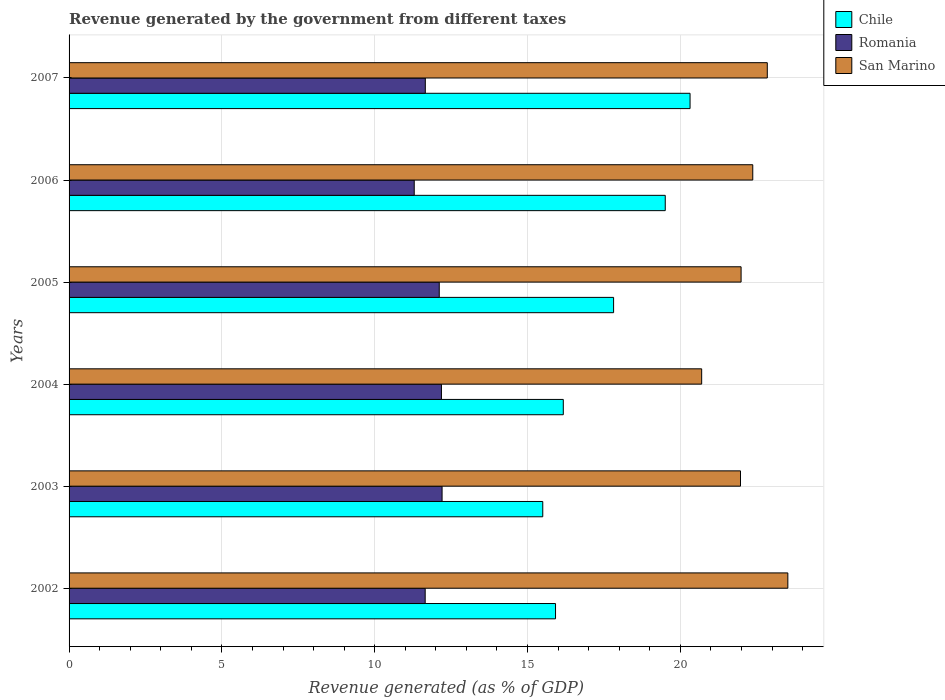How many groups of bars are there?
Provide a succinct answer. 6. Are the number of bars per tick equal to the number of legend labels?
Provide a succinct answer. Yes. Are the number of bars on each tick of the Y-axis equal?
Keep it short and to the point. Yes. How many bars are there on the 1st tick from the bottom?
Your answer should be very brief. 3. What is the label of the 6th group of bars from the top?
Give a very brief answer. 2002. What is the revenue generated by the government in Chile in 2005?
Ensure brevity in your answer.  17.82. Across all years, what is the maximum revenue generated by the government in Chile?
Your response must be concise. 20.32. Across all years, what is the minimum revenue generated by the government in Chile?
Keep it short and to the point. 15.5. In which year was the revenue generated by the government in Romania maximum?
Keep it short and to the point. 2003. What is the total revenue generated by the government in San Marino in the graph?
Provide a succinct answer. 133.39. What is the difference between the revenue generated by the government in Romania in 2004 and that in 2006?
Make the answer very short. 0.89. What is the difference between the revenue generated by the government in Romania in 2006 and the revenue generated by the government in San Marino in 2003?
Make the answer very short. -10.68. What is the average revenue generated by the government in San Marino per year?
Provide a succinct answer. 22.23. In the year 2003, what is the difference between the revenue generated by the government in Chile and revenue generated by the government in Romania?
Your response must be concise. 3.29. What is the ratio of the revenue generated by the government in San Marino in 2003 to that in 2006?
Offer a terse response. 0.98. Is the revenue generated by the government in Chile in 2002 less than that in 2006?
Provide a succinct answer. Yes. What is the difference between the highest and the second highest revenue generated by the government in Chile?
Ensure brevity in your answer.  0.81. What is the difference between the highest and the lowest revenue generated by the government in Romania?
Offer a very short reply. 0.91. In how many years, is the revenue generated by the government in Chile greater than the average revenue generated by the government in Chile taken over all years?
Offer a terse response. 3. Is the sum of the revenue generated by the government in San Marino in 2004 and 2007 greater than the maximum revenue generated by the government in Romania across all years?
Your answer should be compact. Yes. What does the 3rd bar from the top in 2002 represents?
Give a very brief answer. Chile. What does the 3rd bar from the bottom in 2007 represents?
Offer a terse response. San Marino. How many bars are there?
Give a very brief answer. 18. Are all the bars in the graph horizontal?
Keep it short and to the point. Yes. How many years are there in the graph?
Your answer should be very brief. 6. Does the graph contain grids?
Your response must be concise. Yes. What is the title of the graph?
Provide a succinct answer. Revenue generated by the government from different taxes. Does "Mongolia" appear as one of the legend labels in the graph?
Your answer should be compact. No. What is the label or title of the X-axis?
Make the answer very short. Revenue generated (as % of GDP). What is the Revenue generated (as % of GDP) in Chile in 2002?
Ensure brevity in your answer.  15.92. What is the Revenue generated (as % of GDP) of Romania in 2002?
Your answer should be compact. 11.65. What is the Revenue generated (as % of GDP) in San Marino in 2002?
Ensure brevity in your answer.  23.52. What is the Revenue generated (as % of GDP) of Chile in 2003?
Give a very brief answer. 15.5. What is the Revenue generated (as % of GDP) of Romania in 2003?
Ensure brevity in your answer.  12.2. What is the Revenue generated (as % of GDP) in San Marino in 2003?
Keep it short and to the point. 21.97. What is the Revenue generated (as % of GDP) of Chile in 2004?
Your answer should be compact. 16.17. What is the Revenue generated (as % of GDP) in Romania in 2004?
Offer a terse response. 12.18. What is the Revenue generated (as % of GDP) of San Marino in 2004?
Keep it short and to the point. 20.7. What is the Revenue generated (as % of GDP) in Chile in 2005?
Provide a succinct answer. 17.82. What is the Revenue generated (as % of GDP) of Romania in 2005?
Offer a very short reply. 12.11. What is the Revenue generated (as % of GDP) of San Marino in 2005?
Your answer should be compact. 21.99. What is the Revenue generated (as % of GDP) in Chile in 2006?
Provide a short and direct response. 19.51. What is the Revenue generated (as % of GDP) in Romania in 2006?
Keep it short and to the point. 11.29. What is the Revenue generated (as % of GDP) in San Marino in 2006?
Give a very brief answer. 22.37. What is the Revenue generated (as % of GDP) of Chile in 2007?
Keep it short and to the point. 20.32. What is the Revenue generated (as % of GDP) in Romania in 2007?
Your response must be concise. 11.66. What is the Revenue generated (as % of GDP) in San Marino in 2007?
Your answer should be very brief. 22.85. Across all years, what is the maximum Revenue generated (as % of GDP) of Chile?
Your answer should be very brief. 20.32. Across all years, what is the maximum Revenue generated (as % of GDP) in Romania?
Provide a succinct answer. 12.2. Across all years, what is the maximum Revenue generated (as % of GDP) in San Marino?
Offer a very short reply. 23.52. Across all years, what is the minimum Revenue generated (as % of GDP) in Chile?
Offer a terse response. 15.5. Across all years, what is the minimum Revenue generated (as % of GDP) in Romania?
Provide a succinct answer. 11.29. Across all years, what is the minimum Revenue generated (as % of GDP) in San Marino?
Provide a succinct answer. 20.7. What is the total Revenue generated (as % of GDP) in Chile in the graph?
Ensure brevity in your answer.  105.23. What is the total Revenue generated (as % of GDP) of Romania in the graph?
Provide a short and direct response. 71.1. What is the total Revenue generated (as % of GDP) in San Marino in the graph?
Provide a short and direct response. 133.39. What is the difference between the Revenue generated (as % of GDP) of Chile in 2002 and that in 2003?
Your answer should be compact. 0.42. What is the difference between the Revenue generated (as % of GDP) in Romania in 2002 and that in 2003?
Give a very brief answer. -0.55. What is the difference between the Revenue generated (as % of GDP) in San Marino in 2002 and that in 2003?
Provide a succinct answer. 1.55. What is the difference between the Revenue generated (as % of GDP) of Chile in 2002 and that in 2004?
Make the answer very short. -0.25. What is the difference between the Revenue generated (as % of GDP) of Romania in 2002 and that in 2004?
Provide a succinct answer. -0.53. What is the difference between the Revenue generated (as % of GDP) in San Marino in 2002 and that in 2004?
Ensure brevity in your answer.  2.82. What is the difference between the Revenue generated (as % of GDP) in Chile in 2002 and that in 2005?
Keep it short and to the point. -1.9. What is the difference between the Revenue generated (as % of GDP) of Romania in 2002 and that in 2005?
Offer a very short reply. -0.46. What is the difference between the Revenue generated (as % of GDP) of San Marino in 2002 and that in 2005?
Your answer should be compact. 1.53. What is the difference between the Revenue generated (as % of GDP) of Chile in 2002 and that in 2006?
Make the answer very short. -3.59. What is the difference between the Revenue generated (as % of GDP) of Romania in 2002 and that in 2006?
Your answer should be very brief. 0.36. What is the difference between the Revenue generated (as % of GDP) in San Marino in 2002 and that in 2006?
Keep it short and to the point. 1.15. What is the difference between the Revenue generated (as % of GDP) of Chile in 2002 and that in 2007?
Provide a short and direct response. -4.4. What is the difference between the Revenue generated (as % of GDP) of Romania in 2002 and that in 2007?
Your answer should be very brief. -0. What is the difference between the Revenue generated (as % of GDP) of San Marino in 2002 and that in 2007?
Provide a short and direct response. 0.67. What is the difference between the Revenue generated (as % of GDP) in Chile in 2003 and that in 2004?
Your answer should be very brief. -0.67. What is the difference between the Revenue generated (as % of GDP) of Romania in 2003 and that in 2004?
Offer a terse response. 0.02. What is the difference between the Revenue generated (as % of GDP) in San Marino in 2003 and that in 2004?
Offer a terse response. 1.27. What is the difference between the Revenue generated (as % of GDP) in Chile in 2003 and that in 2005?
Provide a succinct answer. -2.32. What is the difference between the Revenue generated (as % of GDP) in Romania in 2003 and that in 2005?
Give a very brief answer. 0.09. What is the difference between the Revenue generated (as % of GDP) of San Marino in 2003 and that in 2005?
Your answer should be very brief. -0.02. What is the difference between the Revenue generated (as % of GDP) of Chile in 2003 and that in 2006?
Provide a succinct answer. -4.01. What is the difference between the Revenue generated (as % of GDP) in Romania in 2003 and that in 2006?
Make the answer very short. 0.91. What is the difference between the Revenue generated (as % of GDP) of San Marino in 2003 and that in 2006?
Keep it short and to the point. -0.4. What is the difference between the Revenue generated (as % of GDP) of Chile in 2003 and that in 2007?
Provide a succinct answer. -4.82. What is the difference between the Revenue generated (as % of GDP) in Romania in 2003 and that in 2007?
Keep it short and to the point. 0.55. What is the difference between the Revenue generated (as % of GDP) in San Marino in 2003 and that in 2007?
Ensure brevity in your answer.  -0.88. What is the difference between the Revenue generated (as % of GDP) in Chile in 2004 and that in 2005?
Make the answer very short. -1.65. What is the difference between the Revenue generated (as % of GDP) of Romania in 2004 and that in 2005?
Ensure brevity in your answer.  0.07. What is the difference between the Revenue generated (as % of GDP) in San Marino in 2004 and that in 2005?
Ensure brevity in your answer.  -1.29. What is the difference between the Revenue generated (as % of GDP) of Chile in 2004 and that in 2006?
Your answer should be compact. -3.34. What is the difference between the Revenue generated (as % of GDP) in Romania in 2004 and that in 2006?
Ensure brevity in your answer.  0.89. What is the difference between the Revenue generated (as % of GDP) in San Marino in 2004 and that in 2006?
Offer a terse response. -1.67. What is the difference between the Revenue generated (as % of GDP) in Chile in 2004 and that in 2007?
Make the answer very short. -4.15. What is the difference between the Revenue generated (as % of GDP) of Romania in 2004 and that in 2007?
Your answer should be very brief. 0.53. What is the difference between the Revenue generated (as % of GDP) of San Marino in 2004 and that in 2007?
Offer a terse response. -2.15. What is the difference between the Revenue generated (as % of GDP) of Chile in 2005 and that in 2006?
Provide a short and direct response. -1.69. What is the difference between the Revenue generated (as % of GDP) of Romania in 2005 and that in 2006?
Your answer should be compact. 0.82. What is the difference between the Revenue generated (as % of GDP) of San Marino in 2005 and that in 2006?
Make the answer very short. -0.38. What is the difference between the Revenue generated (as % of GDP) of Chile in 2005 and that in 2007?
Offer a terse response. -2.5. What is the difference between the Revenue generated (as % of GDP) of Romania in 2005 and that in 2007?
Provide a short and direct response. 0.46. What is the difference between the Revenue generated (as % of GDP) in San Marino in 2005 and that in 2007?
Offer a terse response. -0.86. What is the difference between the Revenue generated (as % of GDP) in Chile in 2006 and that in 2007?
Provide a succinct answer. -0.81. What is the difference between the Revenue generated (as % of GDP) in Romania in 2006 and that in 2007?
Your answer should be compact. -0.36. What is the difference between the Revenue generated (as % of GDP) of San Marino in 2006 and that in 2007?
Keep it short and to the point. -0.48. What is the difference between the Revenue generated (as % of GDP) of Chile in 2002 and the Revenue generated (as % of GDP) of Romania in 2003?
Offer a very short reply. 3.71. What is the difference between the Revenue generated (as % of GDP) in Chile in 2002 and the Revenue generated (as % of GDP) in San Marino in 2003?
Your answer should be compact. -6.05. What is the difference between the Revenue generated (as % of GDP) in Romania in 2002 and the Revenue generated (as % of GDP) in San Marino in 2003?
Ensure brevity in your answer.  -10.32. What is the difference between the Revenue generated (as % of GDP) in Chile in 2002 and the Revenue generated (as % of GDP) in Romania in 2004?
Your answer should be very brief. 3.73. What is the difference between the Revenue generated (as % of GDP) of Chile in 2002 and the Revenue generated (as % of GDP) of San Marino in 2004?
Offer a very short reply. -4.78. What is the difference between the Revenue generated (as % of GDP) of Romania in 2002 and the Revenue generated (as % of GDP) of San Marino in 2004?
Provide a short and direct response. -9.05. What is the difference between the Revenue generated (as % of GDP) of Chile in 2002 and the Revenue generated (as % of GDP) of Romania in 2005?
Ensure brevity in your answer.  3.8. What is the difference between the Revenue generated (as % of GDP) of Chile in 2002 and the Revenue generated (as % of GDP) of San Marino in 2005?
Give a very brief answer. -6.07. What is the difference between the Revenue generated (as % of GDP) in Romania in 2002 and the Revenue generated (as % of GDP) in San Marino in 2005?
Offer a terse response. -10.34. What is the difference between the Revenue generated (as % of GDP) of Chile in 2002 and the Revenue generated (as % of GDP) of Romania in 2006?
Offer a terse response. 4.62. What is the difference between the Revenue generated (as % of GDP) of Chile in 2002 and the Revenue generated (as % of GDP) of San Marino in 2006?
Keep it short and to the point. -6.45. What is the difference between the Revenue generated (as % of GDP) in Romania in 2002 and the Revenue generated (as % of GDP) in San Marino in 2006?
Your answer should be very brief. -10.72. What is the difference between the Revenue generated (as % of GDP) in Chile in 2002 and the Revenue generated (as % of GDP) in Romania in 2007?
Your answer should be very brief. 4.26. What is the difference between the Revenue generated (as % of GDP) of Chile in 2002 and the Revenue generated (as % of GDP) of San Marino in 2007?
Provide a short and direct response. -6.93. What is the difference between the Revenue generated (as % of GDP) of Romania in 2002 and the Revenue generated (as % of GDP) of San Marino in 2007?
Keep it short and to the point. -11.19. What is the difference between the Revenue generated (as % of GDP) in Chile in 2003 and the Revenue generated (as % of GDP) in Romania in 2004?
Keep it short and to the point. 3.31. What is the difference between the Revenue generated (as % of GDP) in Chile in 2003 and the Revenue generated (as % of GDP) in San Marino in 2004?
Make the answer very short. -5.2. What is the difference between the Revenue generated (as % of GDP) of Romania in 2003 and the Revenue generated (as % of GDP) of San Marino in 2004?
Provide a short and direct response. -8.49. What is the difference between the Revenue generated (as % of GDP) of Chile in 2003 and the Revenue generated (as % of GDP) of Romania in 2005?
Make the answer very short. 3.39. What is the difference between the Revenue generated (as % of GDP) of Chile in 2003 and the Revenue generated (as % of GDP) of San Marino in 2005?
Offer a very short reply. -6.49. What is the difference between the Revenue generated (as % of GDP) in Romania in 2003 and the Revenue generated (as % of GDP) in San Marino in 2005?
Ensure brevity in your answer.  -9.78. What is the difference between the Revenue generated (as % of GDP) in Chile in 2003 and the Revenue generated (as % of GDP) in Romania in 2006?
Provide a short and direct response. 4.21. What is the difference between the Revenue generated (as % of GDP) in Chile in 2003 and the Revenue generated (as % of GDP) in San Marino in 2006?
Your answer should be compact. -6.87. What is the difference between the Revenue generated (as % of GDP) in Romania in 2003 and the Revenue generated (as % of GDP) in San Marino in 2006?
Provide a succinct answer. -10.17. What is the difference between the Revenue generated (as % of GDP) of Chile in 2003 and the Revenue generated (as % of GDP) of Romania in 2007?
Your answer should be very brief. 3.84. What is the difference between the Revenue generated (as % of GDP) in Chile in 2003 and the Revenue generated (as % of GDP) in San Marino in 2007?
Provide a short and direct response. -7.35. What is the difference between the Revenue generated (as % of GDP) in Romania in 2003 and the Revenue generated (as % of GDP) in San Marino in 2007?
Keep it short and to the point. -10.64. What is the difference between the Revenue generated (as % of GDP) in Chile in 2004 and the Revenue generated (as % of GDP) in Romania in 2005?
Ensure brevity in your answer.  4.06. What is the difference between the Revenue generated (as % of GDP) in Chile in 2004 and the Revenue generated (as % of GDP) in San Marino in 2005?
Your response must be concise. -5.82. What is the difference between the Revenue generated (as % of GDP) of Romania in 2004 and the Revenue generated (as % of GDP) of San Marino in 2005?
Give a very brief answer. -9.8. What is the difference between the Revenue generated (as % of GDP) of Chile in 2004 and the Revenue generated (as % of GDP) of Romania in 2006?
Keep it short and to the point. 4.88. What is the difference between the Revenue generated (as % of GDP) of Chile in 2004 and the Revenue generated (as % of GDP) of San Marino in 2006?
Your answer should be compact. -6.2. What is the difference between the Revenue generated (as % of GDP) in Romania in 2004 and the Revenue generated (as % of GDP) in San Marino in 2006?
Provide a succinct answer. -10.19. What is the difference between the Revenue generated (as % of GDP) of Chile in 2004 and the Revenue generated (as % of GDP) of Romania in 2007?
Give a very brief answer. 4.51. What is the difference between the Revenue generated (as % of GDP) of Chile in 2004 and the Revenue generated (as % of GDP) of San Marino in 2007?
Make the answer very short. -6.67. What is the difference between the Revenue generated (as % of GDP) in Romania in 2004 and the Revenue generated (as % of GDP) in San Marino in 2007?
Your answer should be compact. -10.66. What is the difference between the Revenue generated (as % of GDP) of Chile in 2005 and the Revenue generated (as % of GDP) of Romania in 2006?
Ensure brevity in your answer.  6.52. What is the difference between the Revenue generated (as % of GDP) in Chile in 2005 and the Revenue generated (as % of GDP) in San Marino in 2006?
Give a very brief answer. -4.55. What is the difference between the Revenue generated (as % of GDP) in Romania in 2005 and the Revenue generated (as % of GDP) in San Marino in 2006?
Keep it short and to the point. -10.26. What is the difference between the Revenue generated (as % of GDP) of Chile in 2005 and the Revenue generated (as % of GDP) of Romania in 2007?
Ensure brevity in your answer.  6.16. What is the difference between the Revenue generated (as % of GDP) of Chile in 2005 and the Revenue generated (as % of GDP) of San Marino in 2007?
Your answer should be very brief. -5.03. What is the difference between the Revenue generated (as % of GDP) of Romania in 2005 and the Revenue generated (as % of GDP) of San Marino in 2007?
Offer a terse response. -10.73. What is the difference between the Revenue generated (as % of GDP) in Chile in 2006 and the Revenue generated (as % of GDP) in Romania in 2007?
Offer a terse response. 7.85. What is the difference between the Revenue generated (as % of GDP) of Chile in 2006 and the Revenue generated (as % of GDP) of San Marino in 2007?
Ensure brevity in your answer.  -3.34. What is the difference between the Revenue generated (as % of GDP) of Romania in 2006 and the Revenue generated (as % of GDP) of San Marino in 2007?
Make the answer very short. -11.55. What is the average Revenue generated (as % of GDP) of Chile per year?
Give a very brief answer. 17.54. What is the average Revenue generated (as % of GDP) in Romania per year?
Provide a succinct answer. 11.85. What is the average Revenue generated (as % of GDP) in San Marino per year?
Keep it short and to the point. 22.23. In the year 2002, what is the difference between the Revenue generated (as % of GDP) of Chile and Revenue generated (as % of GDP) of Romania?
Make the answer very short. 4.27. In the year 2002, what is the difference between the Revenue generated (as % of GDP) in Chile and Revenue generated (as % of GDP) in San Marino?
Provide a succinct answer. -7.6. In the year 2002, what is the difference between the Revenue generated (as % of GDP) in Romania and Revenue generated (as % of GDP) in San Marino?
Your answer should be very brief. -11.87. In the year 2003, what is the difference between the Revenue generated (as % of GDP) of Chile and Revenue generated (as % of GDP) of Romania?
Your answer should be very brief. 3.29. In the year 2003, what is the difference between the Revenue generated (as % of GDP) in Chile and Revenue generated (as % of GDP) in San Marino?
Give a very brief answer. -6.47. In the year 2003, what is the difference between the Revenue generated (as % of GDP) in Romania and Revenue generated (as % of GDP) in San Marino?
Offer a very short reply. -9.76. In the year 2004, what is the difference between the Revenue generated (as % of GDP) of Chile and Revenue generated (as % of GDP) of Romania?
Your answer should be very brief. 3.99. In the year 2004, what is the difference between the Revenue generated (as % of GDP) in Chile and Revenue generated (as % of GDP) in San Marino?
Make the answer very short. -4.53. In the year 2004, what is the difference between the Revenue generated (as % of GDP) in Romania and Revenue generated (as % of GDP) in San Marino?
Offer a terse response. -8.51. In the year 2005, what is the difference between the Revenue generated (as % of GDP) of Chile and Revenue generated (as % of GDP) of Romania?
Your response must be concise. 5.7. In the year 2005, what is the difference between the Revenue generated (as % of GDP) of Chile and Revenue generated (as % of GDP) of San Marino?
Provide a succinct answer. -4.17. In the year 2005, what is the difference between the Revenue generated (as % of GDP) of Romania and Revenue generated (as % of GDP) of San Marino?
Ensure brevity in your answer.  -9.88. In the year 2006, what is the difference between the Revenue generated (as % of GDP) of Chile and Revenue generated (as % of GDP) of Romania?
Your answer should be compact. 8.21. In the year 2006, what is the difference between the Revenue generated (as % of GDP) in Chile and Revenue generated (as % of GDP) in San Marino?
Offer a terse response. -2.86. In the year 2006, what is the difference between the Revenue generated (as % of GDP) of Romania and Revenue generated (as % of GDP) of San Marino?
Give a very brief answer. -11.08. In the year 2007, what is the difference between the Revenue generated (as % of GDP) in Chile and Revenue generated (as % of GDP) in Romania?
Keep it short and to the point. 8.66. In the year 2007, what is the difference between the Revenue generated (as % of GDP) in Chile and Revenue generated (as % of GDP) in San Marino?
Your response must be concise. -2.53. In the year 2007, what is the difference between the Revenue generated (as % of GDP) in Romania and Revenue generated (as % of GDP) in San Marino?
Offer a very short reply. -11.19. What is the ratio of the Revenue generated (as % of GDP) in Romania in 2002 to that in 2003?
Your answer should be very brief. 0.95. What is the ratio of the Revenue generated (as % of GDP) in San Marino in 2002 to that in 2003?
Provide a short and direct response. 1.07. What is the ratio of the Revenue generated (as % of GDP) of Chile in 2002 to that in 2004?
Your answer should be compact. 0.98. What is the ratio of the Revenue generated (as % of GDP) of Romania in 2002 to that in 2004?
Provide a succinct answer. 0.96. What is the ratio of the Revenue generated (as % of GDP) in San Marino in 2002 to that in 2004?
Provide a short and direct response. 1.14. What is the ratio of the Revenue generated (as % of GDP) of Chile in 2002 to that in 2005?
Make the answer very short. 0.89. What is the ratio of the Revenue generated (as % of GDP) in Romania in 2002 to that in 2005?
Your answer should be very brief. 0.96. What is the ratio of the Revenue generated (as % of GDP) of San Marino in 2002 to that in 2005?
Offer a very short reply. 1.07. What is the ratio of the Revenue generated (as % of GDP) of Chile in 2002 to that in 2006?
Your answer should be compact. 0.82. What is the ratio of the Revenue generated (as % of GDP) in Romania in 2002 to that in 2006?
Give a very brief answer. 1.03. What is the ratio of the Revenue generated (as % of GDP) in San Marino in 2002 to that in 2006?
Ensure brevity in your answer.  1.05. What is the ratio of the Revenue generated (as % of GDP) in Chile in 2002 to that in 2007?
Your answer should be compact. 0.78. What is the ratio of the Revenue generated (as % of GDP) in San Marino in 2002 to that in 2007?
Your response must be concise. 1.03. What is the ratio of the Revenue generated (as % of GDP) in Chile in 2003 to that in 2004?
Keep it short and to the point. 0.96. What is the ratio of the Revenue generated (as % of GDP) in San Marino in 2003 to that in 2004?
Offer a very short reply. 1.06. What is the ratio of the Revenue generated (as % of GDP) of Chile in 2003 to that in 2005?
Offer a terse response. 0.87. What is the ratio of the Revenue generated (as % of GDP) in Romania in 2003 to that in 2005?
Offer a terse response. 1.01. What is the ratio of the Revenue generated (as % of GDP) of Chile in 2003 to that in 2006?
Your answer should be very brief. 0.79. What is the ratio of the Revenue generated (as % of GDP) of Romania in 2003 to that in 2006?
Your response must be concise. 1.08. What is the ratio of the Revenue generated (as % of GDP) of San Marino in 2003 to that in 2006?
Give a very brief answer. 0.98. What is the ratio of the Revenue generated (as % of GDP) in Chile in 2003 to that in 2007?
Ensure brevity in your answer.  0.76. What is the ratio of the Revenue generated (as % of GDP) of Romania in 2003 to that in 2007?
Your response must be concise. 1.05. What is the ratio of the Revenue generated (as % of GDP) of San Marino in 2003 to that in 2007?
Offer a terse response. 0.96. What is the ratio of the Revenue generated (as % of GDP) in Chile in 2004 to that in 2005?
Provide a succinct answer. 0.91. What is the ratio of the Revenue generated (as % of GDP) in Romania in 2004 to that in 2005?
Offer a terse response. 1.01. What is the ratio of the Revenue generated (as % of GDP) of San Marino in 2004 to that in 2005?
Offer a very short reply. 0.94. What is the ratio of the Revenue generated (as % of GDP) in Chile in 2004 to that in 2006?
Offer a terse response. 0.83. What is the ratio of the Revenue generated (as % of GDP) in Romania in 2004 to that in 2006?
Make the answer very short. 1.08. What is the ratio of the Revenue generated (as % of GDP) of San Marino in 2004 to that in 2006?
Keep it short and to the point. 0.93. What is the ratio of the Revenue generated (as % of GDP) in Chile in 2004 to that in 2007?
Keep it short and to the point. 0.8. What is the ratio of the Revenue generated (as % of GDP) of Romania in 2004 to that in 2007?
Give a very brief answer. 1.05. What is the ratio of the Revenue generated (as % of GDP) in San Marino in 2004 to that in 2007?
Keep it short and to the point. 0.91. What is the ratio of the Revenue generated (as % of GDP) of Chile in 2005 to that in 2006?
Provide a short and direct response. 0.91. What is the ratio of the Revenue generated (as % of GDP) of Romania in 2005 to that in 2006?
Give a very brief answer. 1.07. What is the ratio of the Revenue generated (as % of GDP) in San Marino in 2005 to that in 2006?
Offer a terse response. 0.98. What is the ratio of the Revenue generated (as % of GDP) of Chile in 2005 to that in 2007?
Offer a terse response. 0.88. What is the ratio of the Revenue generated (as % of GDP) in Romania in 2005 to that in 2007?
Provide a short and direct response. 1.04. What is the ratio of the Revenue generated (as % of GDP) of San Marino in 2005 to that in 2007?
Offer a very short reply. 0.96. What is the ratio of the Revenue generated (as % of GDP) in Chile in 2006 to that in 2007?
Provide a short and direct response. 0.96. What is the ratio of the Revenue generated (as % of GDP) of Romania in 2006 to that in 2007?
Provide a succinct answer. 0.97. What is the ratio of the Revenue generated (as % of GDP) of San Marino in 2006 to that in 2007?
Your response must be concise. 0.98. What is the difference between the highest and the second highest Revenue generated (as % of GDP) of Chile?
Your answer should be very brief. 0.81. What is the difference between the highest and the second highest Revenue generated (as % of GDP) of Romania?
Provide a succinct answer. 0.02. What is the difference between the highest and the second highest Revenue generated (as % of GDP) of San Marino?
Your answer should be very brief. 0.67. What is the difference between the highest and the lowest Revenue generated (as % of GDP) of Chile?
Keep it short and to the point. 4.82. What is the difference between the highest and the lowest Revenue generated (as % of GDP) of Romania?
Offer a terse response. 0.91. What is the difference between the highest and the lowest Revenue generated (as % of GDP) in San Marino?
Make the answer very short. 2.82. 